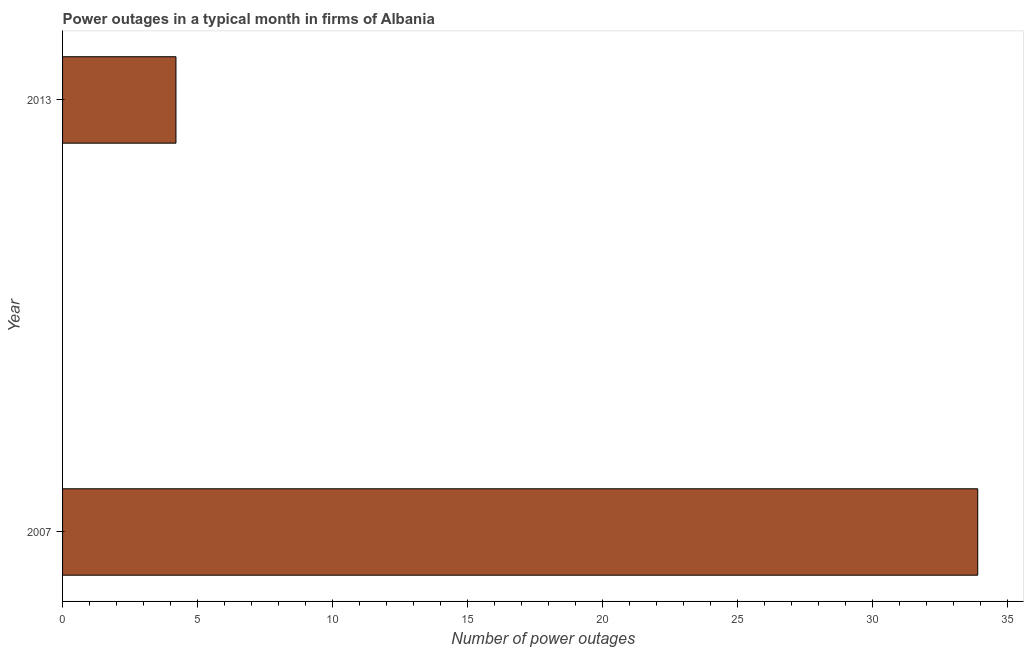Does the graph contain grids?
Make the answer very short. No. What is the title of the graph?
Offer a very short reply. Power outages in a typical month in firms of Albania. What is the label or title of the X-axis?
Ensure brevity in your answer.  Number of power outages. What is the number of power outages in 2007?
Keep it short and to the point. 33.9. Across all years, what is the maximum number of power outages?
Your response must be concise. 33.9. Across all years, what is the minimum number of power outages?
Provide a short and direct response. 4.2. In which year was the number of power outages maximum?
Make the answer very short. 2007. What is the sum of the number of power outages?
Give a very brief answer. 38.1. What is the difference between the number of power outages in 2007 and 2013?
Give a very brief answer. 29.7. What is the average number of power outages per year?
Give a very brief answer. 19.05. What is the median number of power outages?
Offer a very short reply. 19.05. What is the ratio of the number of power outages in 2007 to that in 2013?
Provide a short and direct response. 8.07. Is the number of power outages in 2007 less than that in 2013?
Your answer should be compact. No. In how many years, is the number of power outages greater than the average number of power outages taken over all years?
Offer a terse response. 1. How many bars are there?
Keep it short and to the point. 2. Are all the bars in the graph horizontal?
Offer a very short reply. Yes. How many years are there in the graph?
Your answer should be very brief. 2. What is the difference between two consecutive major ticks on the X-axis?
Provide a succinct answer. 5. What is the Number of power outages of 2007?
Make the answer very short. 33.9. What is the difference between the Number of power outages in 2007 and 2013?
Offer a terse response. 29.7. What is the ratio of the Number of power outages in 2007 to that in 2013?
Keep it short and to the point. 8.07. 